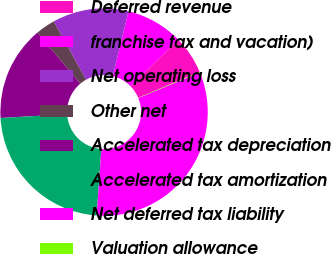Convert chart. <chart><loc_0><loc_0><loc_500><loc_500><pie_chart><fcel>Deferred revenue<fcel>franchise tax and vacation)<fcel>Net operating loss<fcel>Other net<fcel>Accelerated tax depreciation<fcel>Accelerated tax amortization<fcel>Net deferred tax liability<fcel>Valuation allowance<nl><fcel>5.97%<fcel>8.92%<fcel>11.86%<fcel>3.03%<fcel>14.81%<fcel>22.94%<fcel>32.38%<fcel>0.09%<nl></chart> 